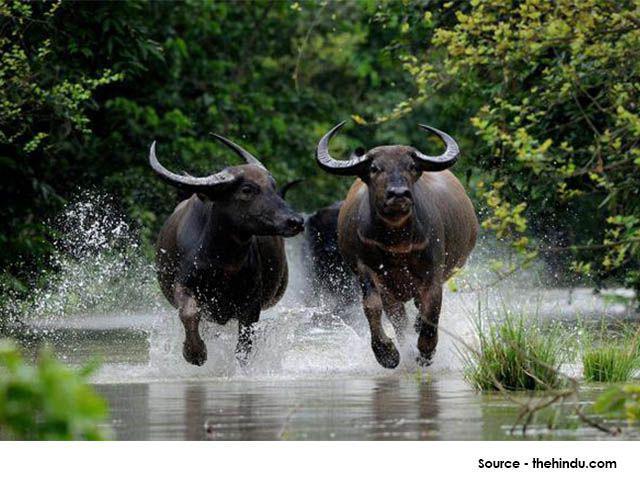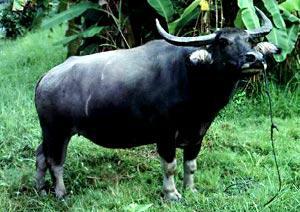The first image is the image on the left, the second image is the image on the right. Examine the images to the left and right. Is the description "An image shows exactly one water buffalo at least waist deep in water." accurate? Answer yes or no. No. The first image is the image on the left, the second image is the image on the right. Evaluate the accuracy of this statement regarding the images: "In one image, a water buffalo is submerged in water with its head and upper body showing.". Is it true? Answer yes or no. No. 